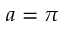Convert formula to latex. <formula><loc_0><loc_0><loc_500><loc_500>a = \pi</formula> 